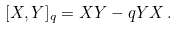<formula> <loc_0><loc_0><loc_500><loc_500>[ X , Y ] _ { q } = X Y - q Y X \, .</formula> 